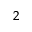<formula> <loc_0><loc_0><loc_500><loc_500>_ { 2 }</formula> 